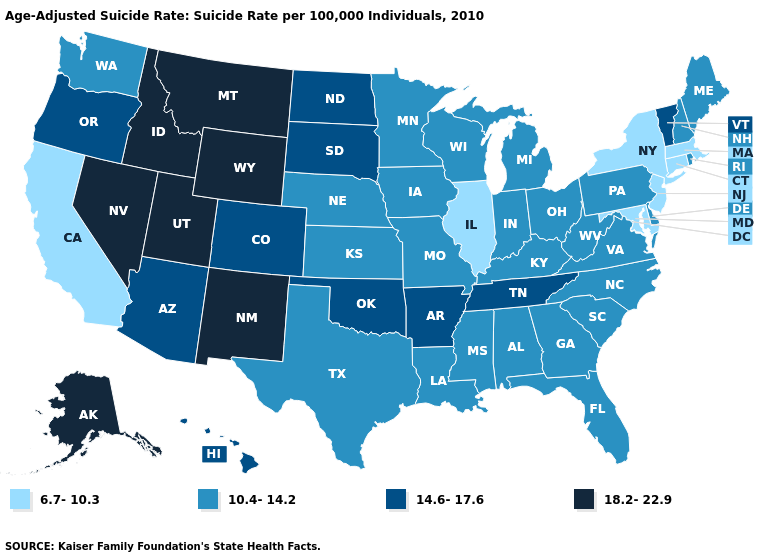Does Vermont have the highest value in the Northeast?
Be succinct. Yes. What is the value of New York?
Be succinct. 6.7-10.3. Which states have the lowest value in the Northeast?
Concise answer only. Connecticut, Massachusetts, New Jersey, New York. What is the value of South Dakota?
Keep it brief. 14.6-17.6. Among the states that border New Mexico , which have the lowest value?
Give a very brief answer. Texas. What is the value of Colorado?
Give a very brief answer. 14.6-17.6. Among the states that border Rhode Island , which have the lowest value?
Be succinct. Connecticut, Massachusetts. Does Alaska have the lowest value in the USA?
Keep it brief. No. Does the map have missing data?
Keep it brief. No. Among the states that border Oregon , which have the lowest value?
Be succinct. California. Name the states that have a value in the range 14.6-17.6?
Keep it brief. Arizona, Arkansas, Colorado, Hawaii, North Dakota, Oklahoma, Oregon, South Dakota, Tennessee, Vermont. Among the states that border Kentucky , does Indiana have the lowest value?
Give a very brief answer. No. What is the value of Alaska?
Short answer required. 18.2-22.9. Which states have the lowest value in the USA?
Quick response, please. California, Connecticut, Illinois, Maryland, Massachusetts, New Jersey, New York. Among the states that border Kansas , does Colorado have the highest value?
Be succinct. Yes. 